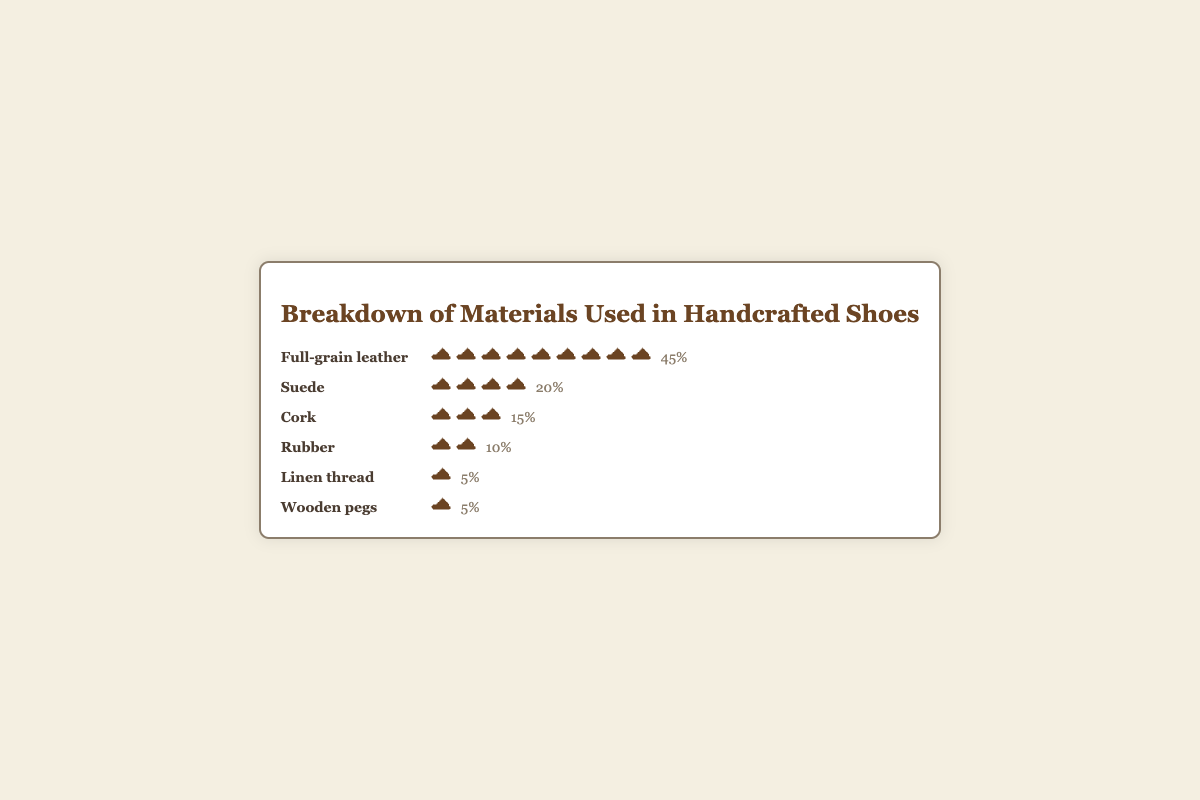What is the most used material in handcrafted shoes according to the plot? The plot shows that Full-grain leather has the most shoe icons and a percentage label of 45%, which is the highest among all materials.
Answer: Full-grain leather How many shoe icons represent Suede? The plot displays 4 shoe icons next to the label 'Suede', indicating its percentage.
Answer: 4 What is the combined percentage of materials that are used equally in the lowest proportion? The materials with the lowest proportion are Linen thread and Wooden pegs, each with 5%. Adding these together gives 5% + 5% = 10%.
Answer: 10% Which material is used more, Rubber or Cork? The plot shows that Rubber has 2 shoe icons and a 10% label, while Cork has 3 shoe icons and a 15% label. Hence, Cork is used more than Rubber.
Answer: Cork If I combine the percentages of Suede, Cork, and Rubber, what would be the total percentage? Adding the percentages of Suede (20%), Cork (15%), and Rubber (10%) results in a total of 20% + 15% + 10% = 45%.
Answer: 45% Which materials are used equally and what is their percentage each? Both Linen thread and Wooden pegs have 1 shoe icon each and are labeled with a percentage of 5%.
Answer: Linen thread and Wooden pegs, 5% What is the difference in usage percentage between Full-grain leather and Rubber? Full-grain leather has a percentage of 45% and Rubber has 10%. The difference is 45% - 10% = 35%.
Answer: 35% Rank the materials from most used to least used based on the plot. By examining the number of shoe icons and percentages: 1. Full-grain leather (45%) 2. Suede (20%) 3. Cork (15%) 4. Rubber (10%) 5. Linen thread (5%) 5. Wooden pegs (5%)
Answer: Full-grain leather, Suede, Cork, Rubber, Linen thread, Wooden pegs What materials make up 60% of the handcrafted shoes together? The materials are Full-grain leather (45%) and Suede (20%). Adding their percentages: 45% + 15% = 60%.
Answer: Full-grain leather, Suede 